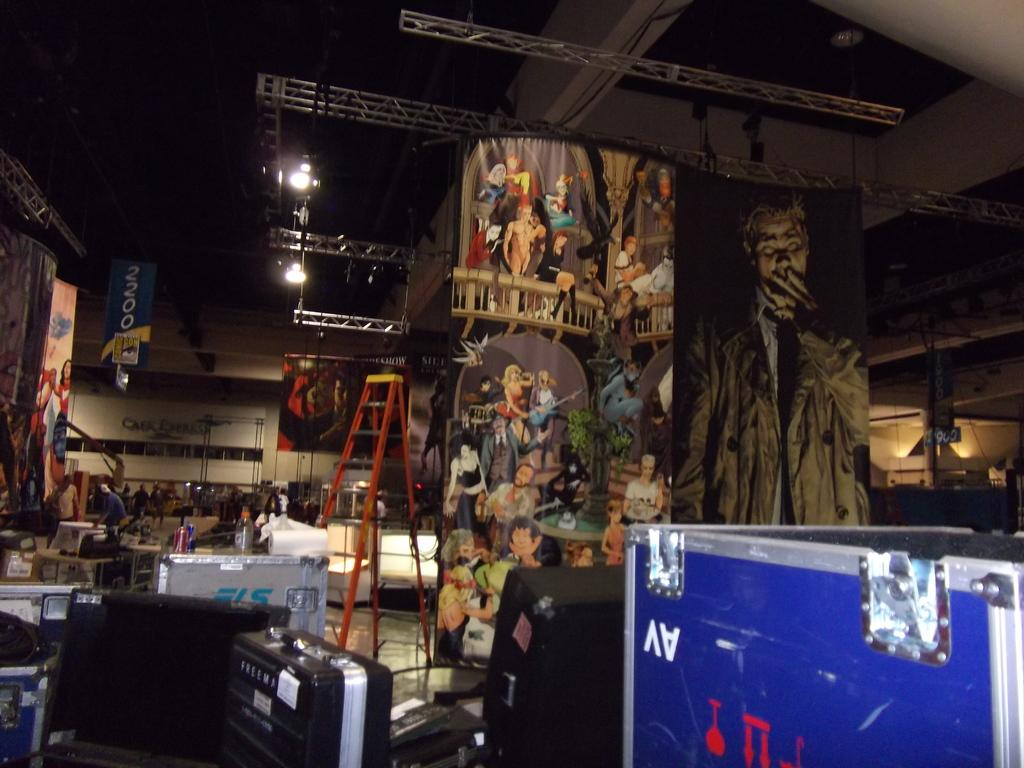What is the main feature of the image? The main feature of the image is a closed area. What can be found inside the closed area? Many things are kept inside the closed area. What type of education is being provided inside the closed area? There is no indication of any education being provided inside the closed area, as the facts only mention that many things are kept inside. 